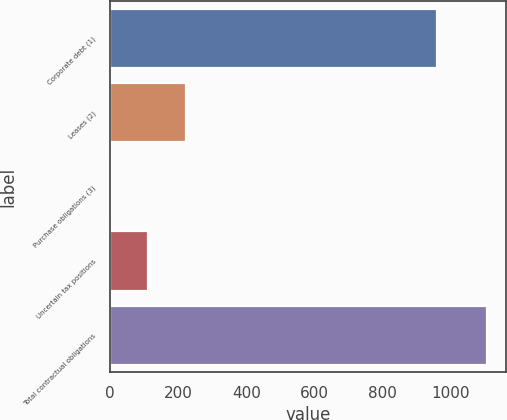<chart> <loc_0><loc_0><loc_500><loc_500><bar_chart><fcel>Corporate debt (1)<fcel>Leases (2)<fcel>Purchase obligations (3)<fcel>Uncertain tax positions<fcel>Total contractual obligations<nl><fcel>959<fcel>222.2<fcel>1<fcel>111.6<fcel>1107<nl></chart> 